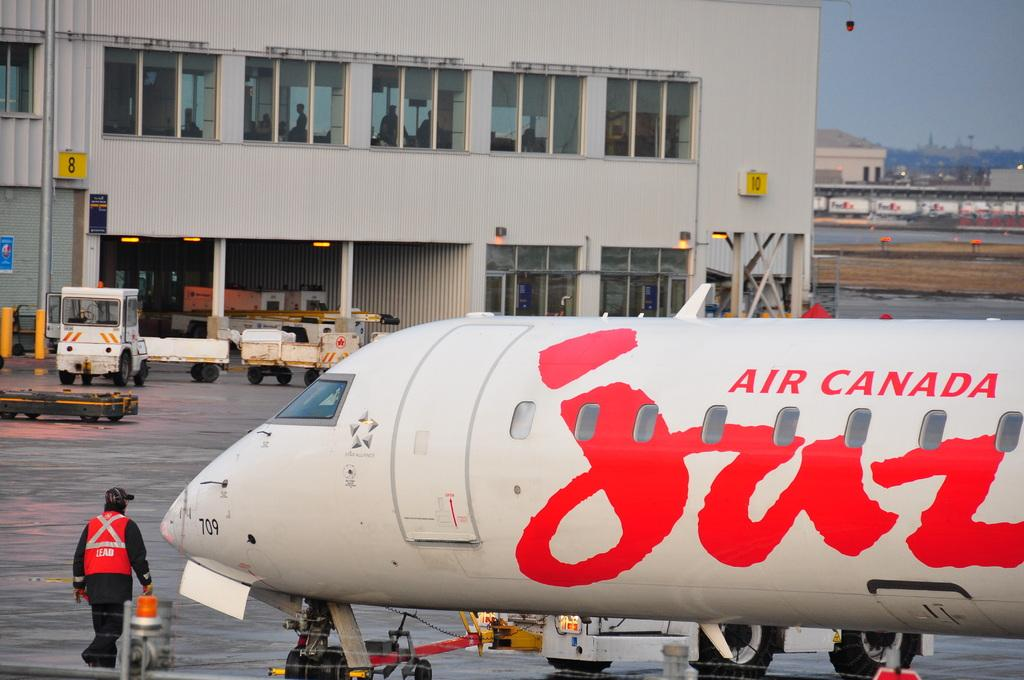<image>
Present a compact description of the photo's key features. An Air Canada airplane sitting on the runway with a building behind it, 